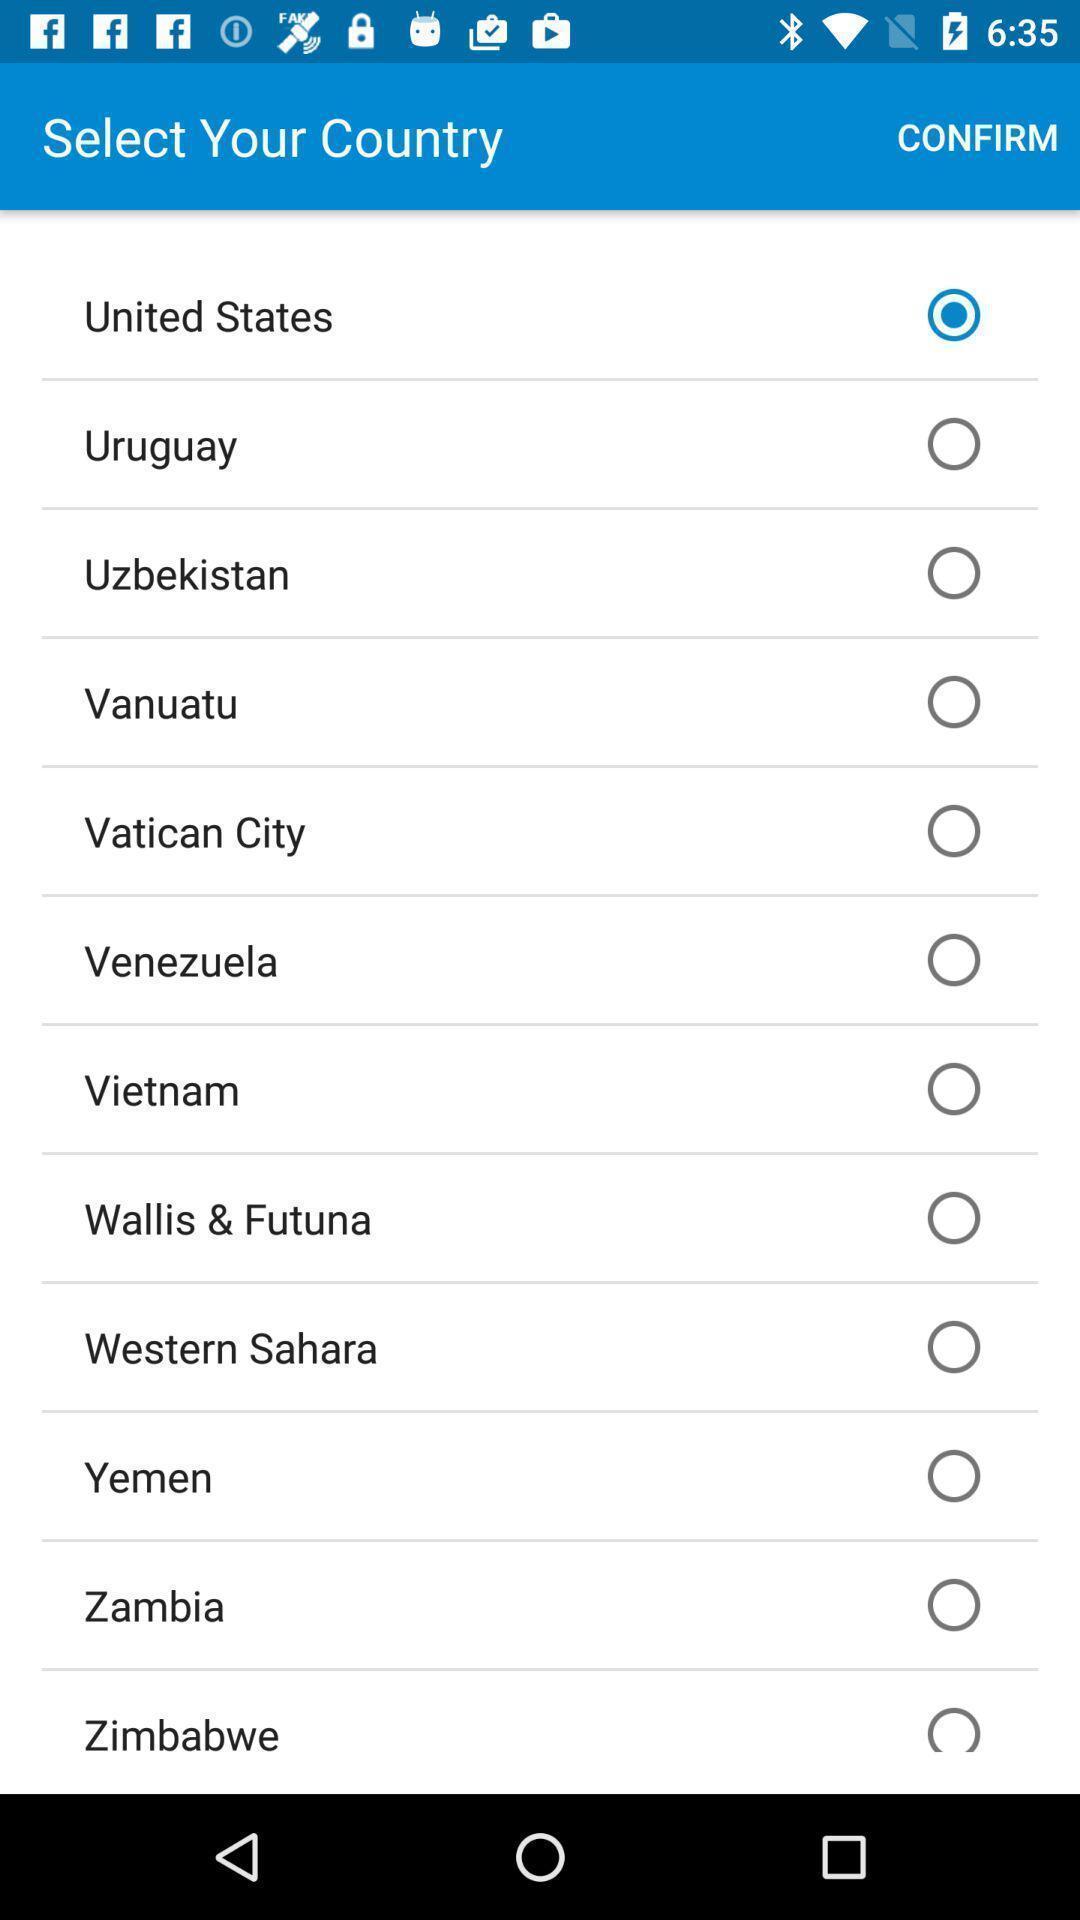What details can you identify in this image? Screen asking to confirm selected country. 